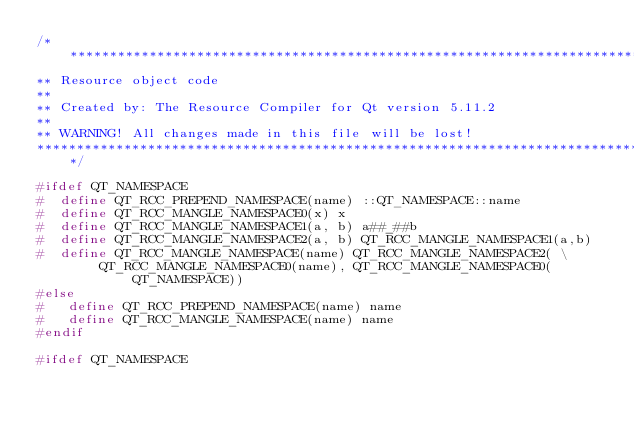Convert code to text. <code><loc_0><loc_0><loc_500><loc_500><_C++_>/****************************************************************************
** Resource object code
**
** Created by: The Resource Compiler for Qt version 5.11.2
**
** WARNING! All changes made in this file will be lost!
*****************************************************************************/

#ifdef QT_NAMESPACE
#  define QT_RCC_PREPEND_NAMESPACE(name) ::QT_NAMESPACE::name
#  define QT_RCC_MANGLE_NAMESPACE0(x) x
#  define QT_RCC_MANGLE_NAMESPACE1(a, b) a##_##b
#  define QT_RCC_MANGLE_NAMESPACE2(a, b) QT_RCC_MANGLE_NAMESPACE1(a,b)
#  define QT_RCC_MANGLE_NAMESPACE(name) QT_RCC_MANGLE_NAMESPACE2( \
        QT_RCC_MANGLE_NAMESPACE0(name), QT_RCC_MANGLE_NAMESPACE0(QT_NAMESPACE))
#else
#   define QT_RCC_PREPEND_NAMESPACE(name) name
#   define QT_RCC_MANGLE_NAMESPACE(name) name
#endif

#ifdef QT_NAMESPACE</code> 